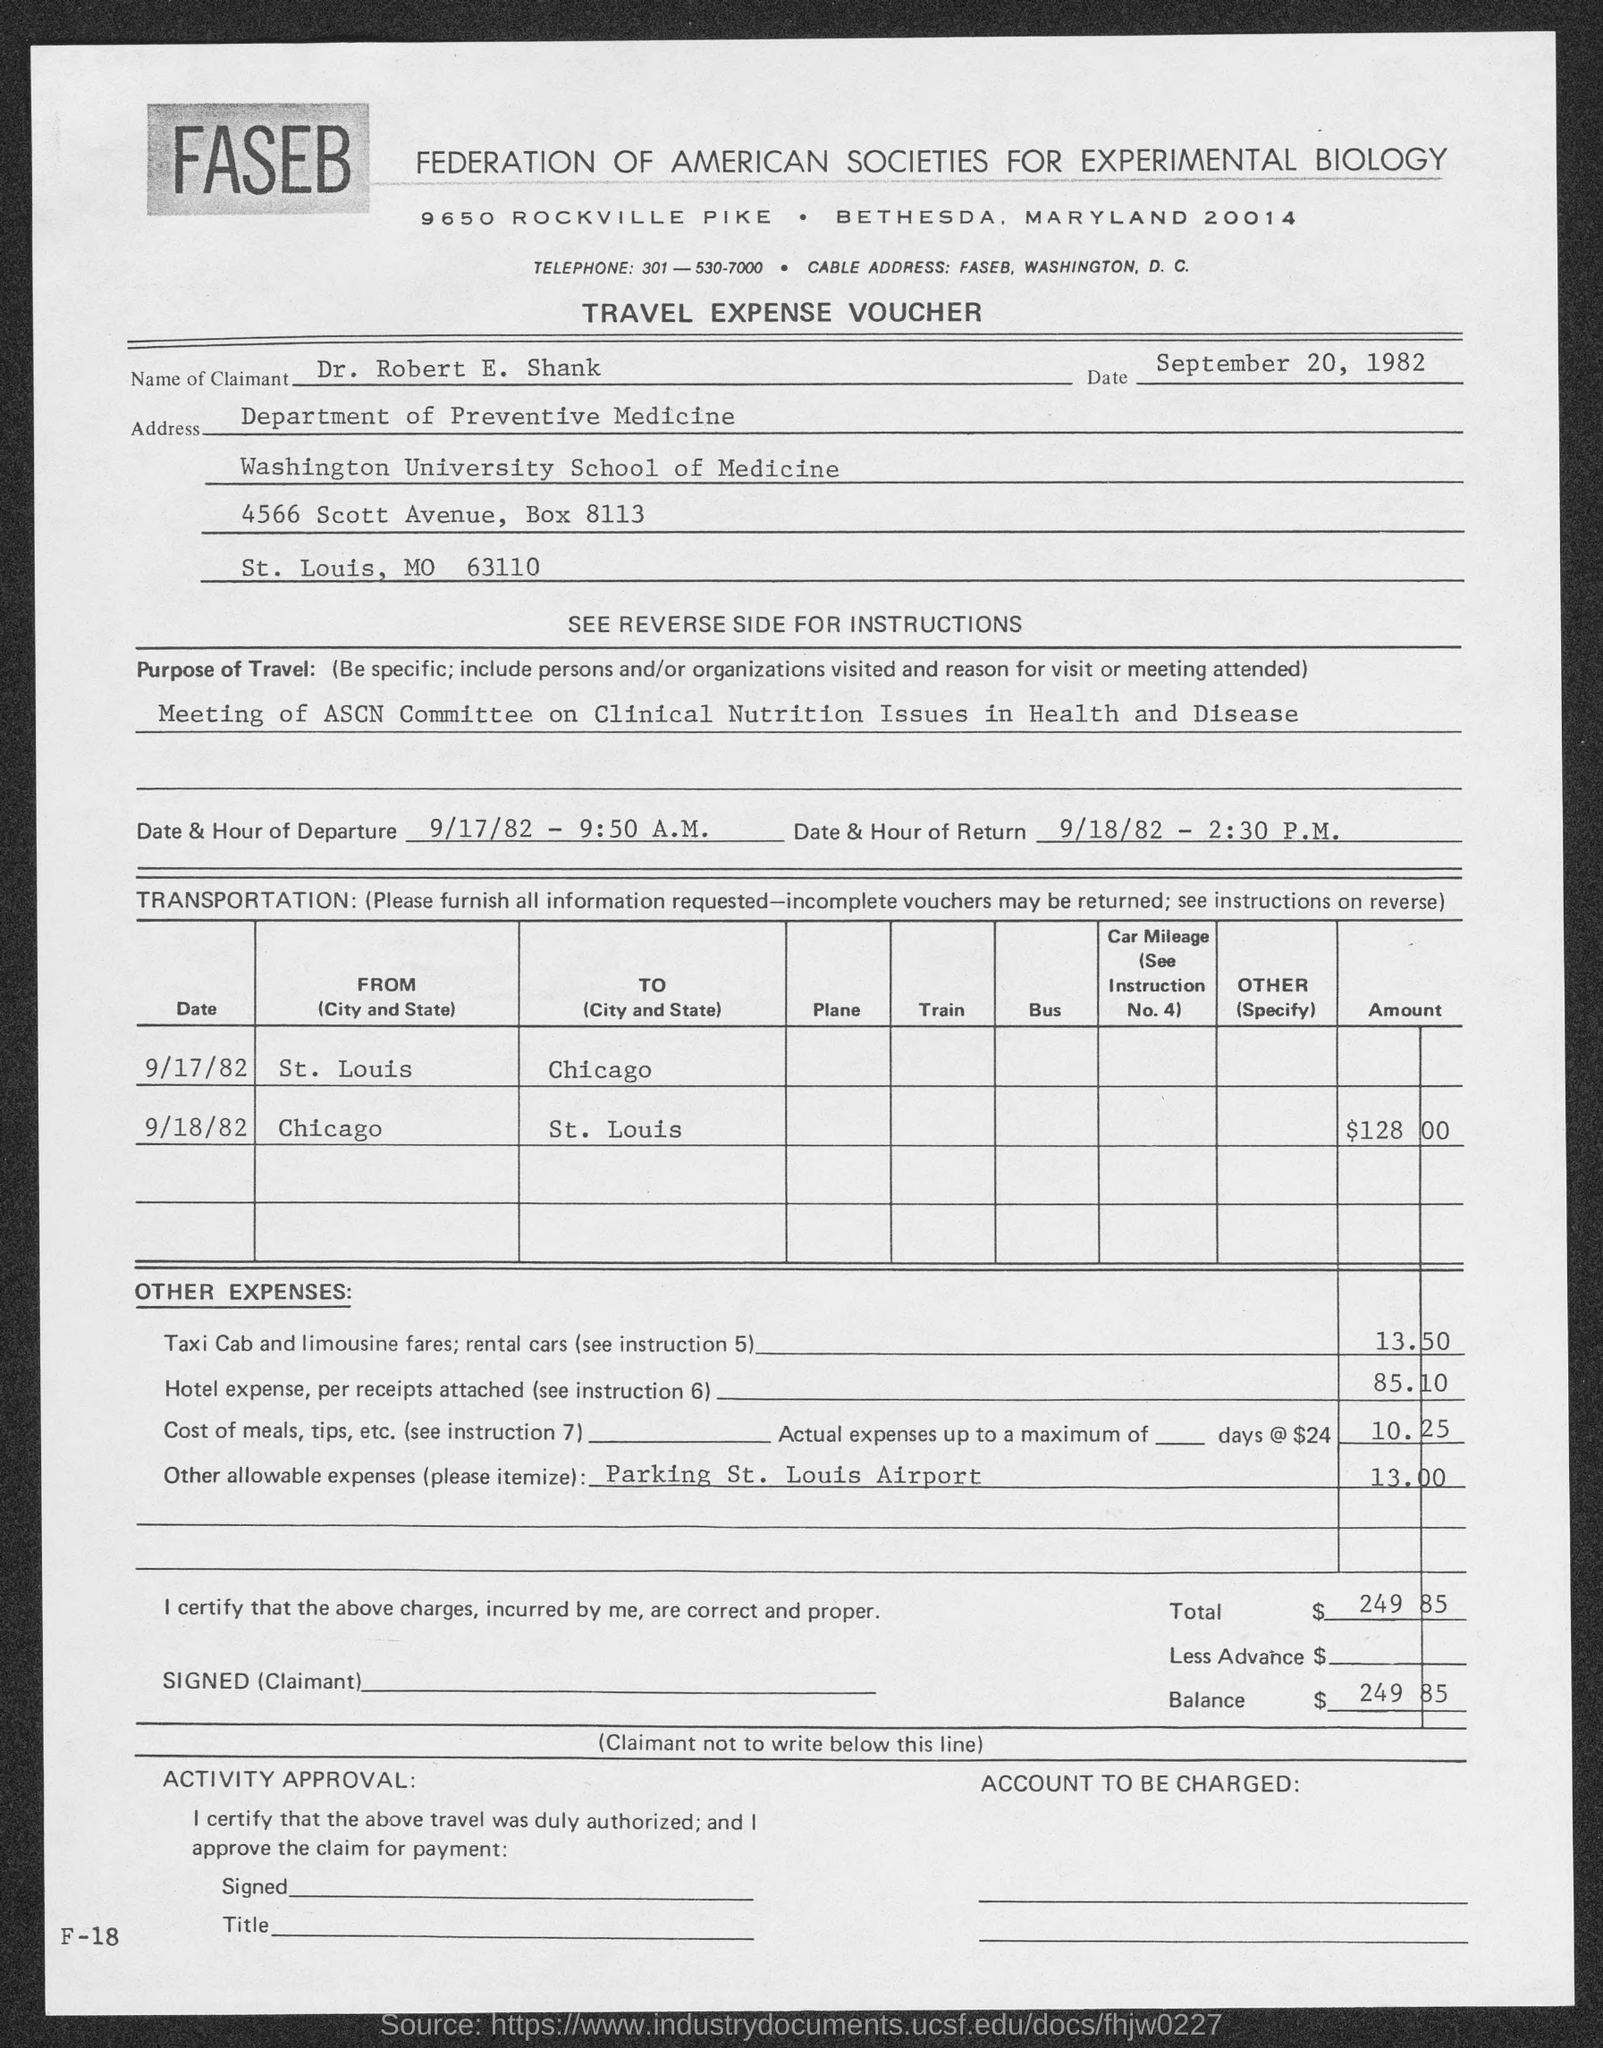In which state is federation of american societies for experimental biology at ?
Give a very brief answer. Maryland. What is the name of claimant ?
Ensure brevity in your answer.  Dr. Robert E. Shank. 